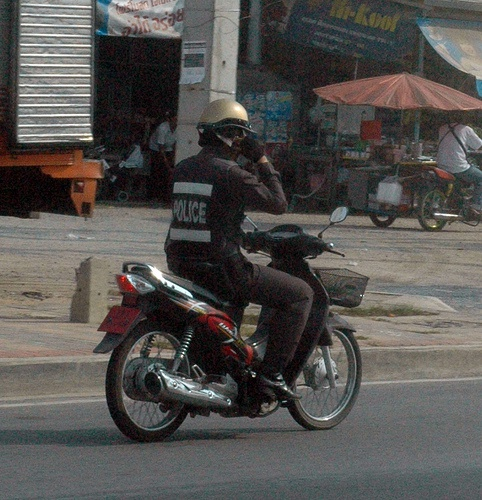Describe the objects in this image and their specific colors. I can see motorcycle in black, gray, maroon, and darkgray tones, truck in black, darkgray, gray, and lightgray tones, people in black, gray, and darkgray tones, umbrella in black, gray, brown, and maroon tones, and people in black, gray, darkgray, and purple tones in this image. 